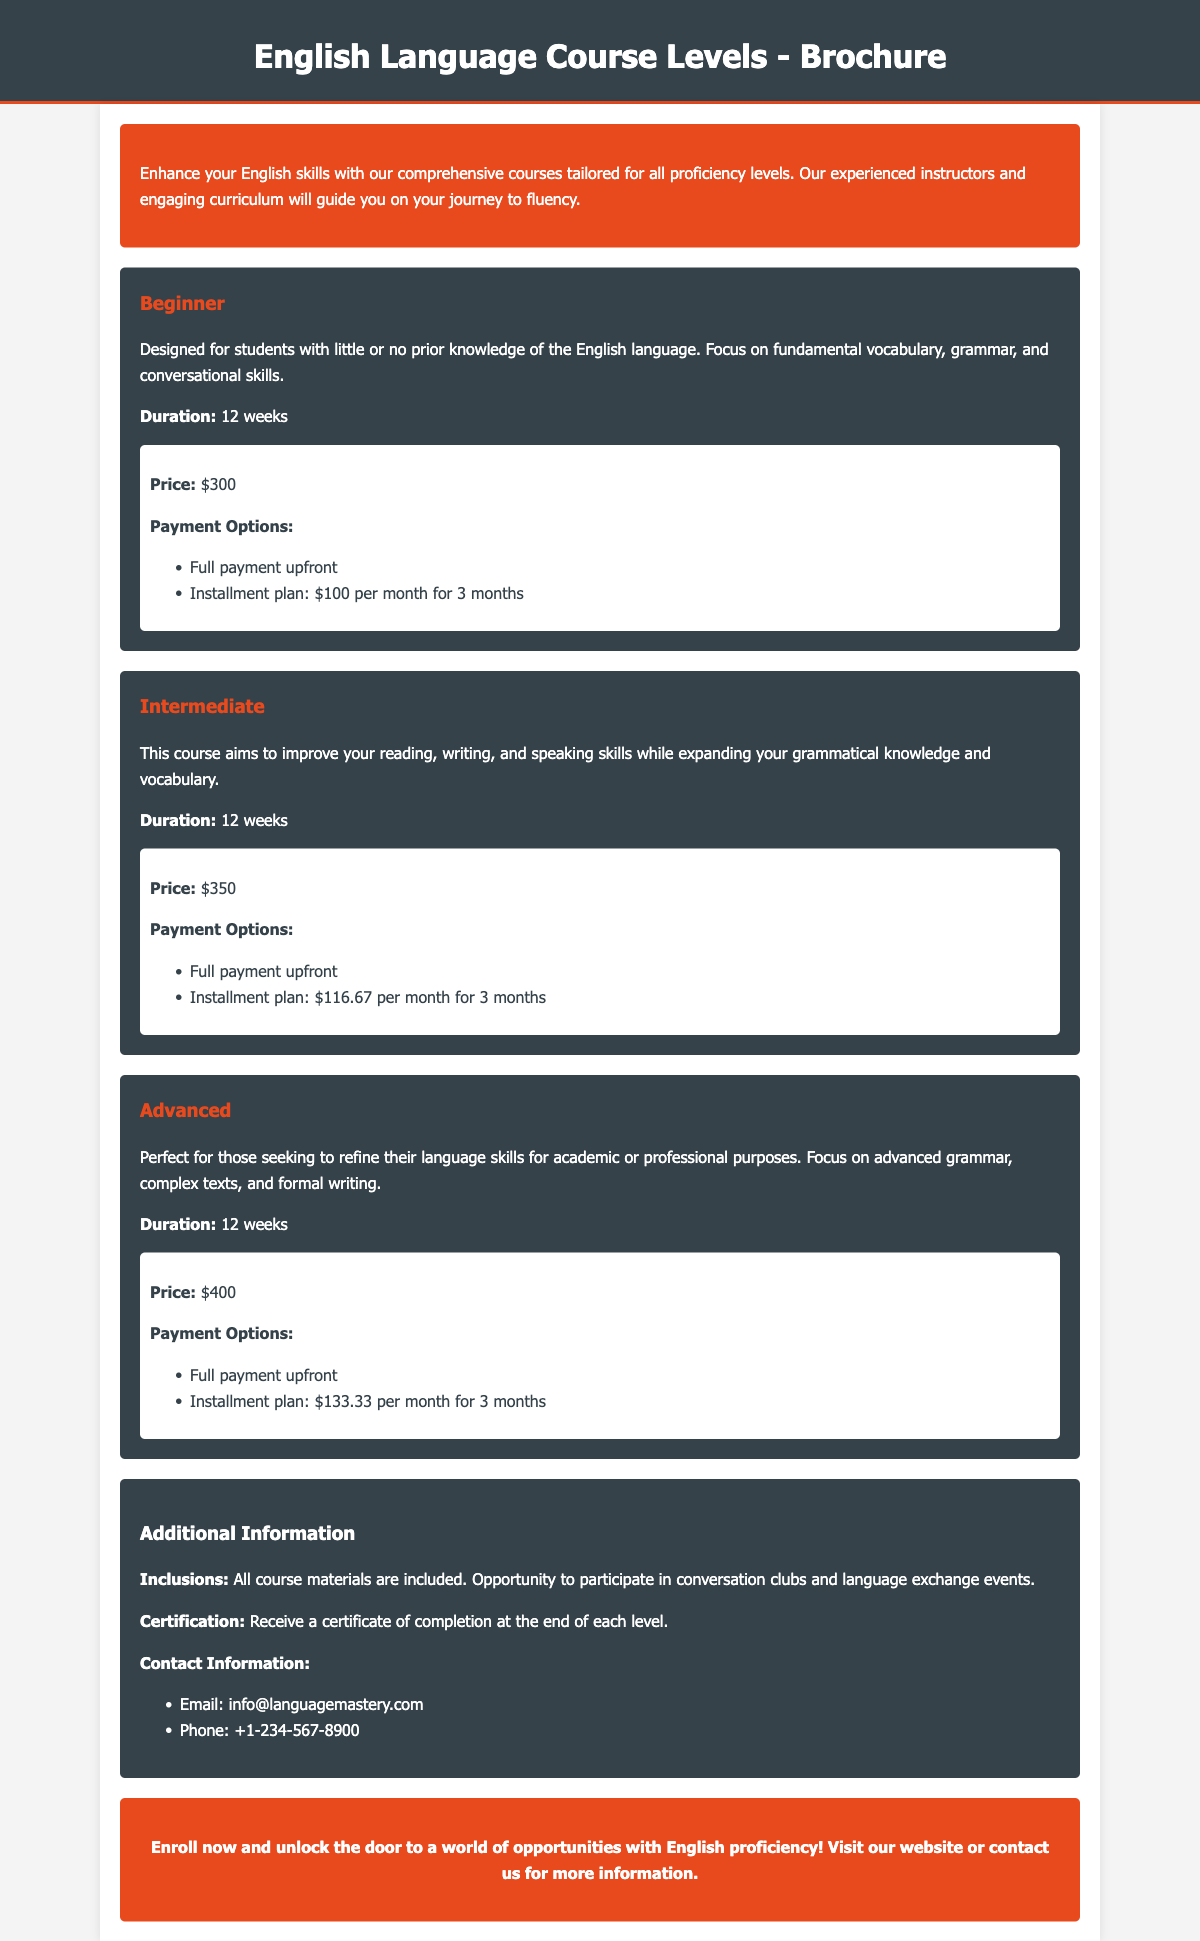what is the duration of the Beginner course? The duration of the Beginner course is specified in the document as 12 weeks.
Answer: 12 weeks what is the price of the Intermediate course? The price of the Intermediate course is listed in the document as $350.
Answer: $350 what is included with the course? The inclusions for the courses include all course materials and participation in conversation clubs and language exchange events.
Answer: All course materials what payment option is available for the Advanced course? The document mentions two payment options for the Advanced course, one of them is the installment plan priced at $133.33 per month for 3 months.
Answer: Installment plan: $133.33 per month for 3 months how many weeks does each course last? The document indicates that all courses, including Beginner, Intermediate, and Advanced, have the same duration of 12 weeks.
Answer: 12 weeks what certification is offered at the end of each level? The document states that students receive a certificate of completion at the end of each level.
Answer: Certificate of completion how can prospective students contact the language school? The document provides contact information, specifically an email and a phone number, for prospective students.
Answer: Email: info@languagemastery.com what is the focus of the Advanced course? The focus of the Advanced course is to refine language skills for academic or professional purposes, emphasizing advanced grammar and formal writing.
Answer: Refine language skills for academic or professional purposes 